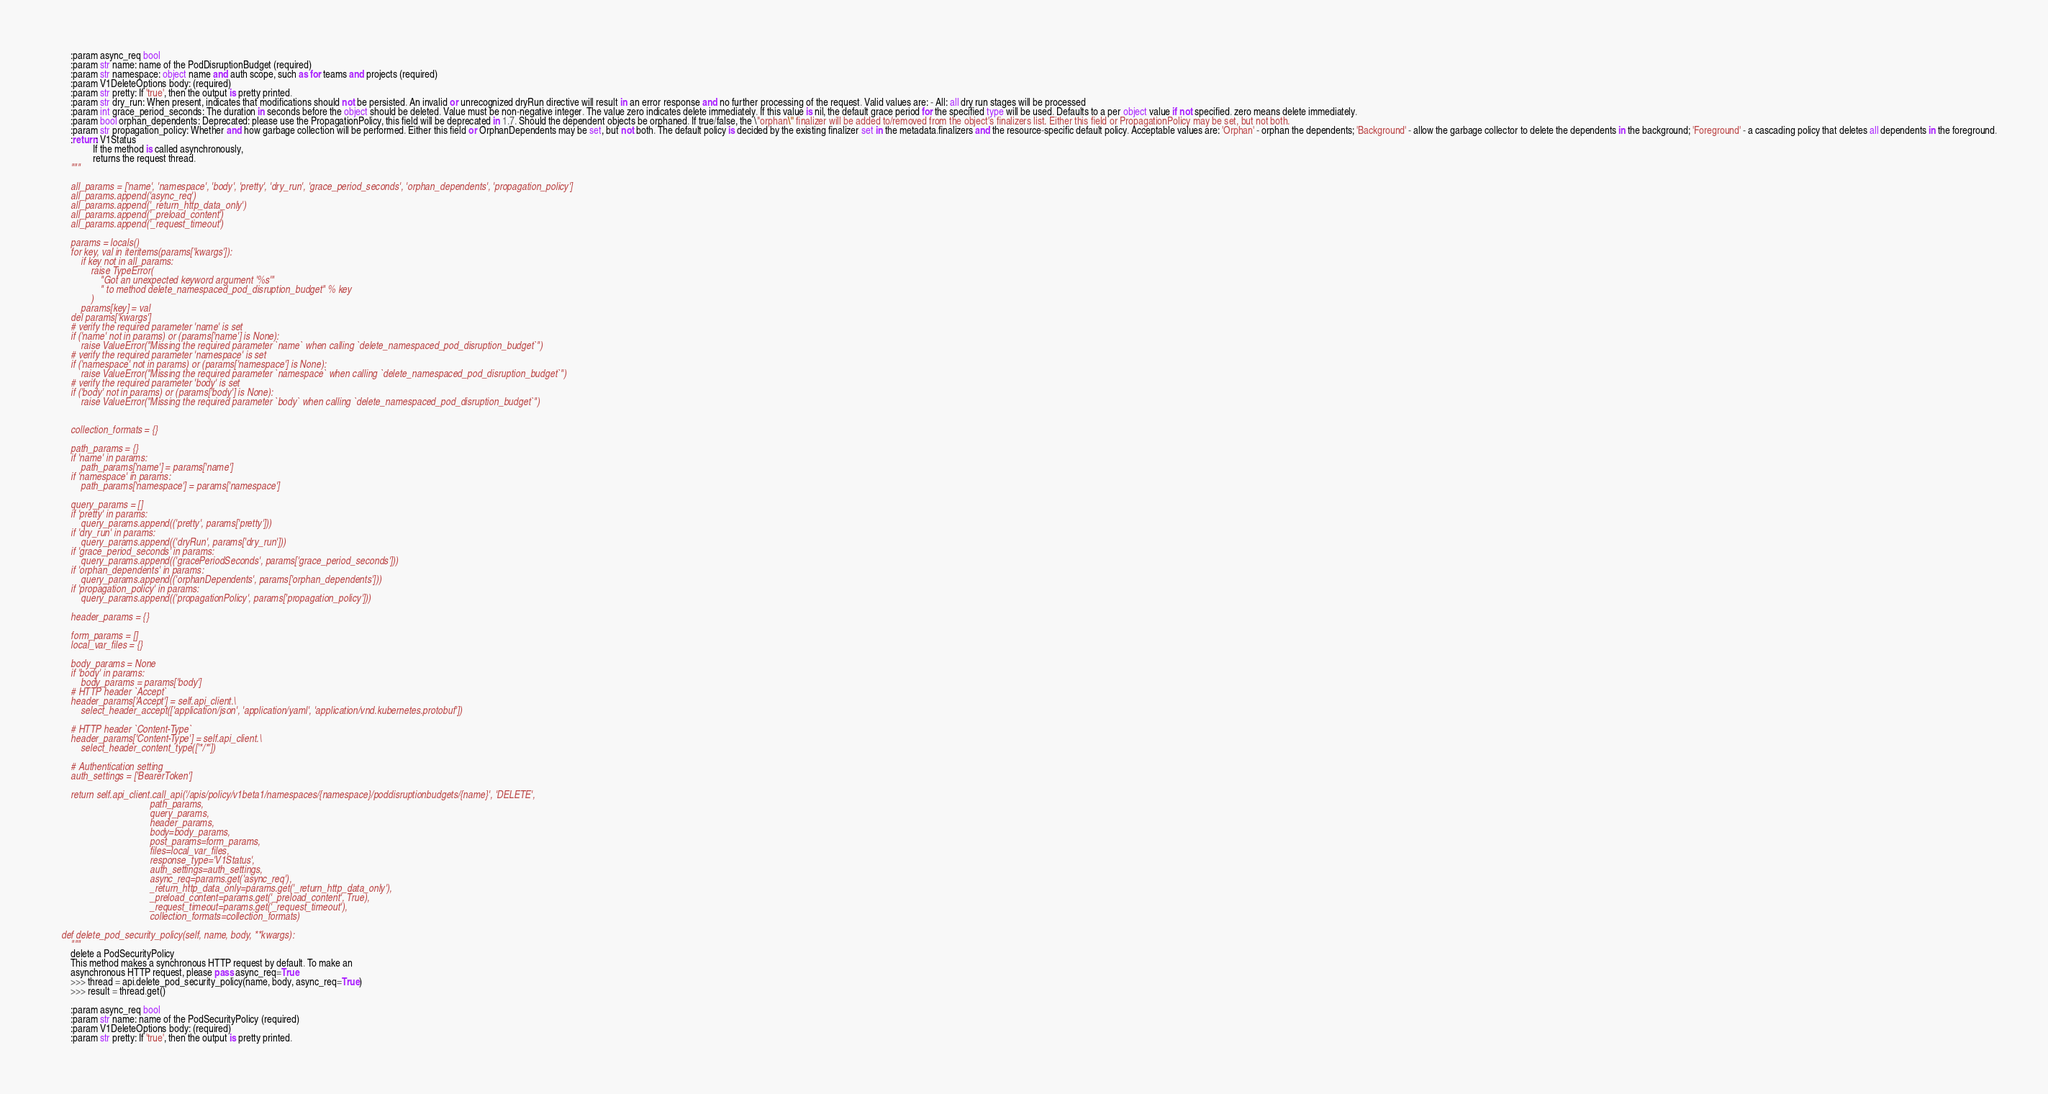Convert code to text. <code><loc_0><loc_0><loc_500><loc_500><_Python_>
        :param async_req bool
        :param str name: name of the PodDisruptionBudget (required)
        :param str namespace: object name and auth scope, such as for teams and projects (required)
        :param V1DeleteOptions body: (required)
        :param str pretty: If 'true', then the output is pretty printed.
        :param str dry_run: When present, indicates that modifications should not be persisted. An invalid or unrecognized dryRun directive will result in an error response and no further processing of the request. Valid values are: - All: all dry run stages will be processed
        :param int grace_period_seconds: The duration in seconds before the object should be deleted. Value must be non-negative integer. The value zero indicates delete immediately. If this value is nil, the default grace period for the specified type will be used. Defaults to a per object value if not specified. zero means delete immediately.
        :param bool orphan_dependents: Deprecated: please use the PropagationPolicy, this field will be deprecated in 1.7. Should the dependent objects be orphaned. If true/false, the \"orphan\" finalizer will be added to/removed from the object's finalizers list. Either this field or PropagationPolicy may be set, but not both.
        :param str propagation_policy: Whether and how garbage collection will be performed. Either this field or OrphanDependents may be set, but not both. The default policy is decided by the existing finalizer set in the metadata.finalizers and the resource-specific default policy. Acceptable values are: 'Orphan' - orphan the dependents; 'Background' - allow the garbage collector to delete the dependents in the background; 'Foreground' - a cascading policy that deletes all dependents in the foreground.
        :return: V1Status
                 If the method is called asynchronously,
                 returns the request thread.
        """

        all_params = ['name', 'namespace', 'body', 'pretty', 'dry_run', 'grace_period_seconds', 'orphan_dependents', 'propagation_policy']
        all_params.append('async_req')
        all_params.append('_return_http_data_only')
        all_params.append('_preload_content')
        all_params.append('_request_timeout')

        params = locals()
        for key, val in iteritems(params['kwargs']):
            if key not in all_params:
                raise TypeError(
                    "Got an unexpected keyword argument '%s'"
                    " to method delete_namespaced_pod_disruption_budget" % key
                )
            params[key] = val
        del params['kwargs']
        # verify the required parameter 'name' is set
        if ('name' not in params) or (params['name'] is None):
            raise ValueError("Missing the required parameter `name` when calling `delete_namespaced_pod_disruption_budget`")
        # verify the required parameter 'namespace' is set
        if ('namespace' not in params) or (params['namespace'] is None):
            raise ValueError("Missing the required parameter `namespace` when calling `delete_namespaced_pod_disruption_budget`")
        # verify the required parameter 'body' is set
        if ('body' not in params) or (params['body'] is None):
            raise ValueError("Missing the required parameter `body` when calling `delete_namespaced_pod_disruption_budget`")


        collection_formats = {}

        path_params = {}
        if 'name' in params:
            path_params['name'] = params['name']
        if 'namespace' in params:
            path_params['namespace'] = params['namespace']

        query_params = []
        if 'pretty' in params:
            query_params.append(('pretty', params['pretty']))
        if 'dry_run' in params:
            query_params.append(('dryRun', params['dry_run']))
        if 'grace_period_seconds' in params:
            query_params.append(('gracePeriodSeconds', params['grace_period_seconds']))
        if 'orphan_dependents' in params:
            query_params.append(('orphanDependents', params['orphan_dependents']))
        if 'propagation_policy' in params:
            query_params.append(('propagationPolicy', params['propagation_policy']))

        header_params = {}

        form_params = []
        local_var_files = {}

        body_params = None
        if 'body' in params:
            body_params = params['body']
        # HTTP header `Accept`
        header_params['Accept'] = self.api_client.\
            select_header_accept(['application/json', 'application/yaml', 'application/vnd.kubernetes.protobuf'])

        # HTTP header `Content-Type`
        header_params['Content-Type'] = self.api_client.\
            select_header_content_type(['*/*'])

        # Authentication setting
        auth_settings = ['BearerToken']

        return self.api_client.call_api('/apis/policy/v1beta1/namespaces/{namespace}/poddisruptionbudgets/{name}', 'DELETE',
                                        path_params,
                                        query_params,
                                        header_params,
                                        body=body_params,
                                        post_params=form_params,
                                        files=local_var_files,
                                        response_type='V1Status',
                                        auth_settings=auth_settings,
                                        async_req=params.get('async_req'),
                                        _return_http_data_only=params.get('_return_http_data_only'),
                                        _preload_content=params.get('_preload_content', True),
                                        _request_timeout=params.get('_request_timeout'),
                                        collection_formats=collection_formats)

    def delete_pod_security_policy(self, name, body, **kwargs):
        """
        delete a PodSecurityPolicy
        This method makes a synchronous HTTP request by default. To make an
        asynchronous HTTP request, please pass async_req=True
        >>> thread = api.delete_pod_security_policy(name, body, async_req=True)
        >>> result = thread.get()

        :param async_req bool
        :param str name: name of the PodSecurityPolicy (required)
        :param V1DeleteOptions body: (required)
        :param str pretty: If 'true', then the output is pretty printed.</code> 